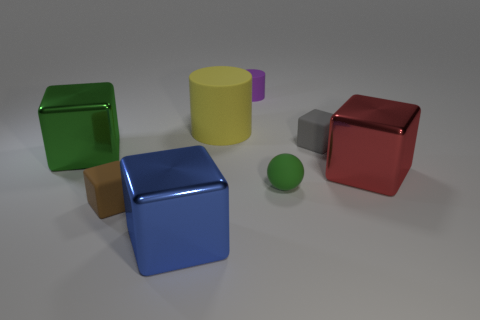Is the purple cylinder the same size as the gray matte cube?
Provide a short and direct response. Yes. There is a large thing that is to the left of the blue cube that is left of the small rubber thing on the right side of the small green object; what shape is it?
Provide a short and direct response. Cube. There is another rubber object that is the same shape as the big yellow object; what is its color?
Offer a very short reply. Purple. There is a object that is both left of the tiny matte ball and on the right side of the large rubber cylinder; what is its size?
Make the answer very short. Small. What number of rubber blocks are behind the object that is on the left side of the rubber block that is left of the small gray object?
Make the answer very short. 1. How many large objects are purple rubber objects or brown matte cubes?
Provide a short and direct response. 0. Are the large cube that is in front of the tiny green rubber sphere and the big red block made of the same material?
Your answer should be compact. Yes. What is the large object in front of the small rubber cube that is in front of the large metal block that is to the left of the brown thing made of?
Make the answer very short. Metal. Is there anything else that has the same size as the green cube?
Provide a short and direct response. Yes. What number of matte things are red things or small green spheres?
Provide a short and direct response. 1. 